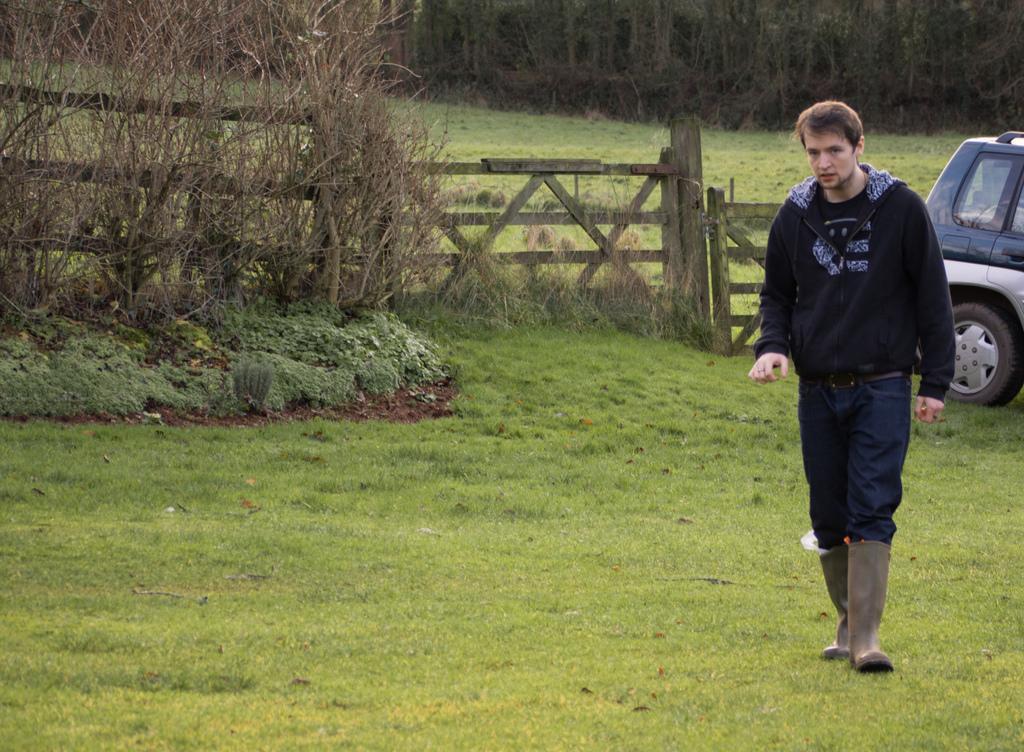Could you give a brief overview of what you see in this image? In this image, we can see a person and a vehicle. We can see the ground covered with grass. There are a few plants and trees. Among them, we can see some dried trees. 